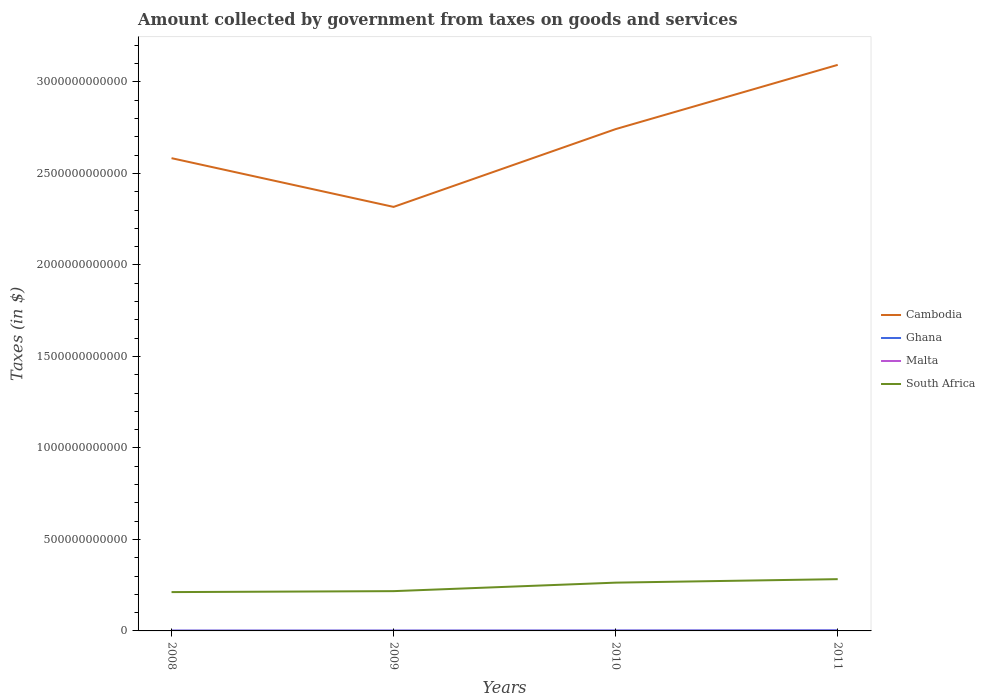Does the line corresponding to Ghana intersect with the line corresponding to Malta?
Your answer should be compact. No. Is the number of lines equal to the number of legend labels?
Offer a very short reply. Yes. Across all years, what is the maximum amount collected by government from taxes on goods and services in South Africa?
Provide a succinct answer. 2.12e+11. In which year was the amount collected by government from taxes on goods and services in South Africa maximum?
Your answer should be very brief. 2008. What is the total amount collected by government from taxes on goods and services in South Africa in the graph?
Make the answer very short. -1.90e+1. What is the difference between the highest and the second highest amount collected by government from taxes on goods and services in Cambodia?
Provide a short and direct response. 7.76e+11. How many lines are there?
Offer a terse response. 4. How many years are there in the graph?
Provide a short and direct response. 4. What is the difference between two consecutive major ticks on the Y-axis?
Provide a short and direct response. 5.00e+11. How are the legend labels stacked?
Ensure brevity in your answer.  Vertical. What is the title of the graph?
Your response must be concise. Amount collected by government from taxes on goods and services. What is the label or title of the Y-axis?
Ensure brevity in your answer.  Taxes (in $). What is the Taxes (in $) in Cambodia in 2008?
Provide a short and direct response. 2.58e+12. What is the Taxes (in $) of Ghana in 2008?
Offer a terse response. 1.86e+09. What is the Taxes (in $) of Malta in 2008?
Provide a short and direct response. 7.96e+08. What is the Taxes (in $) of South Africa in 2008?
Keep it short and to the point. 2.12e+11. What is the Taxes (in $) in Cambodia in 2009?
Provide a short and direct response. 2.32e+12. What is the Taxes (in $) in Ghana in 2009?
Give a very brief answer. 2.00e+09. What is the Taxes (in $) of Malta in 2009?
Provide a succinct answer. 8.01e+08. What is the Taxes (in $) in South Africa in 2009?
Your answer should be compact. 2.17e+11. What is the Taxes (in $) in Cambodia in 2010?
Ensure brevity in your answer.  2.74e+12. What is the Taxes (in $) of Ghana in 2010?
Make the answer very short. 2.44e+09. What is the Taxes (in $) in Malta in 2010?
Ensure brevity in your answer.  8.29e+08. What is the Taxes (in $) of South Africa in 2010?
Your answer should be very brief. 2.64e+11. What is the Taxes (in $) in Cambodia in 2011?
Your answer should be very brief. 3.09e+12. What is the Taxes (in $) of Ghana in 2011?
Your answer should be compact. 3.55e+09. What is the Taxes (in $) in Malta in 2011?
Give a very brief answer. 8.92e+08. What is the Taxes (in $) in South Africa in 2011?
Give a very brief answer. 2.83e+11. Across all years, what is the maximum Taxes (in $) in Cambodia?
Provide a short and direct response. 3.09e+12. Across all years, what is the maximum Taxes (in $) of Ghana?
Make the answer very short. 3.55e+09. Across all years, what is the maximum Taxes (in $) of Malta?
Give a very brief answer. 8.92e+08. Across all years, what is the maximum Taxes (in $) of South Africa?
Keep it short and to the point. 2.83e+11. Across all years, what is the minimum Taxes (in $) in Cambodia?
Make the answer very short. 2.32e+12. Across all years, what is the minimum Taxes (in $) of Ghana?
Your answer should be compact. 1.86e+09. Across all years, what is the minimum Taxes (in $) of Malta?
Offer a terse response. 7.96e+08. Across all years, what is the minimum Taxes (in $) in South Africa?
Provide a short and direct response. 2.12e+11. What is the total Taxes (in $) of Cambodia in the graph?
Provide a succinct answer. 1.07e+13. What is the total Taxes (in $) of Ghana in the graph?
Offer a very short reply. 9.85e+09. What is the total Taxes (in $) of Malta in the graph?
Provide a short and direct response. 3.32e+09. What is the total Taxes (in $) in South Africa in the graph?
Your answer should be very brief. 9.76e+11. What is the difference between the Taxes (in $) of Cambodia in 2008 and that in 2009?
Provide a succinct answer. 2.66e+11. What is the difference between the Taxes (in $) of Ghana in 2008 and that in 2009?
Make the answer very short. -1.33e+08. What is the difference between the Taxes (in $) of Malta in 2008 and that in 2009?
Your answer should be very brief. -4.79e+06. What is the difference between the Taxes (in $) of South Africa in 2008 and that in 2009?
Offer a very short reply. -5.19e+09. What is the difference between the Taxes (in $) of Cambodia in 2008 and that in 2010?
Provide a succinct answer. -1.59e+11. What is the difference between the Taxes (in $) in Ghana in 2008 and that in 2010?
Your answer should be very brief. -5.73e+08. What is the difference between the Taxes (in $) in Malta in 2008 and that in 2010?
Provide a succinct answer. -3.33e+07. What is the difference between the Taxes (in $) of South Africa in 2008 and that in 2010?
Ensure brevity in your answer.  -5.17e+1. What is the difference between the Taxes (in $) in Cambodia in 2008 and that in 2011?
Provide a succinct answer. -5.10e+11. What is the difference between the Taxes (in $) in Ghana in 2008 and that in 2011?
Give a very brief answer. -1.69e+09. What is the difference between the Taxes (in $) of Malta in 2008 and that in 2011?
Ensure brevity in your answer.  -9.64e+07. What is the difference between the Taxes (in $) in South Africa in 2008 and that in 2011?
Provide a succinct answer. -7.07e+1. What is the difference between the Taxes (in $) of Cambodia in 2009 and that in 2010?
Give a very brief answer. -4.25e+11. What is the difference between the Taxes (in $) in Ghana in 2009 and that in 2010?
Offer a very short reply. -4.40e+08. What is the difference between the Taxes (in $) in Malta in 2009 and that in 2010?
Keep it short and to the point. -2.85e+07. What is the difference between the Taxes (in $) of South Africa in 2009 and that in 2010?
Offer a terse response. -4.65e+1. What is the difference between the Taxes (in $) in Cambodia in 2009 and that in 2011?
Offer a terse response. -7.76e+11. What is the difference between the Taxes (in $) in Ghana in 2009 and that in 2011?
Offer a terse response. -1.55e+09. What is the difference between the Taxes (in $) of Malta in 2009 and that in 2011?
Your answer should be very brief. -9.16e+07. What is the difference between the Taxes (in $) of South Africa in 2009 and that in 2011?
Provide a succinct answer. -6.55e+1. What is the difference between the Taxes (in $) in Cambodia in 2010 and that in 2011?
Ensure brevity in your answer.  -3.51e+11. What is the difference between the Taxes (in $) of Ghana in 2010 and that in 2011?
Ensure brevity in your answer.  -1.11e+09. What is the difference between the Taxes (in $) of Malta in 2010 and that in 2011?
Make the answer very short. -6.32e+07. What is the difference between the Taxes (in $) of South Africa in 2010 and that in 2011?
Provide a succinct answer. -1.90e+1. What is the difference between the Taxes (in $) of Cambodia in 2008 and the Taxes (in $) of Ghana in 2009?
Make the answer very short. 2.58e+12. What is the difference between the Taxes (in $) in Cambodia in 2008 and the Taxes (in $) in Malta in 2009?
Your response must be concise. 2.58e+12. What is the difference between the Taxes (in $) in Cambodia in 2008 and the Taxes (in $) in South Africa in 2009?
Your answer should be very brief. 2.37e+12. What is the difference between the Taxes (in $) in Ghana in 2008 and the Taxes (in $) in Malta in 2009?
Offer a very short reply. 1.06e+09. What is the difference between the Taxes (in $) in Ghana in 2008 and the Taxes (in $) in South Africa in 2009?
Ensure brevity in your answer.  -2.16e+11. What is the difference between the Taxes (in $) of Malta in 2008 and the Taxes (in $) of South Africa in 2009?
Ensure brevity in your answer.  -2.17e+11. What is the difference between the Taxes (in $) in Cambodia in 2008 and the Taxes (in $) in Ghana in 2010?
Offer a terse response. 2.58e+12. What is the difference between the Taxes (in $) in Cambodia in 2008 and the Taxes (in $) in Malta in 2010?
Ensure brevity in your answer.  2.58e+12. What is the difference between the Taxes (in $) of Cambodia in 2008 and the Taxes (in $) of South Africa in 2010?
Provide a succinct answer. 2.32e+12. What is the difference between the Taxes (in $) of Ghana in 2008 and the Taxes (in $) of Malta in 2010?
Your response must be concise. 1.03e+09. What is the difference between the Taxes (in $) of Ghana in 2008 and the Taxes (in $) of South Africa in 2010?
Keep it short and to the point. -2.62e+11. What is the difference between the Taxes (in $) in Malta in 2008 and the Taxes (in $) in South Africa in 2010?
Offer a very short reply. -2.63e+11. What is the difference between the Taxes (in $) in Cambodia in 2008 and the Taxes (in $) in Ghana in 2011?
Provide a succinct answer. 2.58e+12. What is the difference between the Taxes (in $) in Cambodia in 2008 and the Taxes (in $) in Malta in 2011?
Ensure brevity in your answer.  2.58e+12. What is the difference between the Taxes (in $) of Cambodia in 2008 and the Taxes (in $) of South Africa in 2011?
Your answer should be very brief. 2.30e+12. What is the difference between the Taxes (in $) of Ghana in 2008 and the Taxes (in $) of Malta in 2011?
Ensure brevity in your answer.  9.71e+08. What is the difference between the Taxes (in $) in Ghana in 2008 and the Taxes (in $) in South Africa in 2011?
Your answer should be compact. -2.81e+11. What is the difference between the Taxes (in $) of Malta in 2008 and the Taxes (in $) of South Africa in 2011?
Your answer should be compact. -2.82e+11. What is the difference between the Taxes (in $) in Cambodia in 2009 and the Taxes (in $) in Ghana in 2010?
Keep it short and to the point. 2.31e+12. What is the difference between the Taxes (in $) of Cambodia in 2009 and the Taxes (in $) of Malta in 2010?
Provide a short and direct response. 2.32e+12. What is the difference between the Taxes (in $) of Cambodia in 2009 and the Taxes (in $) of South Africa in 2010?
Your answer should be very brief. 2.05e+12. What is the difference between the Taxes (in $) of Ghana in 2009 and the Taxes (in $) of Malta in 2010?
Provide a short and direct response. 1.17e+09. What is the difference between the Taxes (in $) in Ghana in 2009 and the Taxes (in $) in South Africa in 2010?
Give a very brief answer. -2.62e+11. What is the difference between the Taxes (in $) of Malta in 2009 and the Taxes (in $) of South Africa in 2010?
Offer a very short reply. -2.63e+11. What is the difference between the Taxes (in $) of Cambodia in 2009 and the Taxes (in $) of Ghana in 2011?
Your response must be concise. 2.31e+12. What is the difference between the Taxes (in $) of Cambodia in 2009 and the Taxes (in $) of Malta in 2011?
Keep it short and to the point. 2.32e+12. What is the difference between the Taxes (in $) in Cambodia in 2009 and the Taxes (in $) in South Africa in 2011?
Your answer should be very brief. 2.03e+12. What is the difference between the Taxes (in $) of Ghana in 2009 and the Taxes (in $) of Malta in 2011?
Offer a very short reply. 1.10e+09. What is the difference between the Taxes (in $) of Ghana in 2009 and the Taxes (in $) of South Africa in 2011?
Provide a succinct answer. -2.81e+11. What is the difference between the Taxes (in $) of Malta in 2009 and the Taxes (in $) of South Africa in 2011?
Ensure brevity in your answer.  -2.82e+11. What is the difference between the Taxes (in $) in Cambodia in 2010 and the Taxes (in $) in Ghana in 2011?
Your response must be concise. 2.74e+12. What is the difference between the Taxes (in $) of Cambodia in 2010 and the Taxes (in $) of Malta in 2011?
Offer a terse response. 2.74e+12. What is the difference between the Taxes (in $) in Cambodia in 2010 and the Taxes (in $) in South Africa in 2011?
Your answer should be very brief. 2.46e+12. What is the difference between the Taxes (in $) in Ghana in 2010 and the Taxes (in $) in Malta in 2011?
Offer a terse response. 1.54e+09. What is the difference between the Taxes (in $) in Ghana in 2010 and the Taxes (in $) in South Africa in 2011?
Your answer should be compact. -2.80e+11. What is the difference between the Taxes (in $) of Malta in 2010 and the Taxes (in $) of South Africa in 2011?
Ensure brevity in your answer.  -2.82e+11. What is the average Taxes (in $) of Cambodia per year?
Provide a short and direct response. 2.68e+12. What is the average Taxes (in $) of Ghana per year?
Offer a very short reply. 2.46e+09. What is the average Taxes (in $) of Malta per year?
Provide a succinct answer. 8.30e+08. What is the average Taxes (in $) in South Africa per year?
Provide a short and direct response. 2.44e+11. In the year 2008, what is the difference between the Taxes (in $) of Cambodia and Taxes (in $) of Ghana?
Provide a succinct answer. 2.58e+12. In the year 2008, what is the difference between the Taxes (in $) in Cambodia and Taxes (in $) in Malta?
Provide a succinct answer. 2.58e+12. In the year 2008, what is the difference between the Taxes (in $) of Cambodia and Taxes (in $) of South Africa?
Ensure brevity in your answer.  2.37e+12. In the year 2008, what is the difference between the Taxes (in $) in Ghana and Taxes (in $) in Malta?
Your answer should be very brief. 1.07e+09. In the year 2008, what is the difference between the Taxes (in $) in Ghana and Taxes (in $) in South Africa?
Provide a short and direct response. -2.10e+11. In the year 2008, what is the difference between the Taxes (in $) in Malta and Taxes (in $) in South Africa?
Provide a short and direct response. -2.11e+11. In the year 2009, what is the difference between the Taxes (in $) of Cambodia and Taxes (in $) of Ghana?
Offer a terse response. 2.32e+12. In the year 2009, what is the difference between the Taxes (in $) of Cambodia and Taxes (in $) of Malta?
Make the answer very short. 2.32e+12. In the year 2009, what is the difference between the Taxes (in $) of Cambodia and Taxes (in $) of South Africa?
Offer a terse response. 2.10e+12. In the year 2009, what is the difference between the Taxes (in $) in Ghana and Taxes (in $) in Malta?
Offer a terse response. 1.20e+09. In the year 2009, what is the difference between the Taxes (in $) in Ghana and Taxes (in $) in South Africa?
Ensure brevity in your answer.  -2.15e+11. In the year 2009, what is the difference between the Taxes (in $) of Malta and Taxes (in $) of South Africa?
Provide a succinct answer. -2.17e+11. In the year 2010, what is the difference between the Taxes (in $) of Cambodia and Taxes (in $) of Ghana?
Make the answer very short. 2.74e+12. In the year 2010, what is the difference between the Taxes (in $) in Cambodia and Taxes (in $) in Malta?
Your answer should be very brief. 2.74e+12. In the year 2010, what is the difference between the Taxes (in $) in Cambodia and Taxes (in $) in South Africa?
Your answer should be compact. 2.48e+12. In the year 2010, what is the difference between the Taxes (in $) of Ghana and Taxes (in $) of Malta?
Your answer should be compact. 1.61e+09. In the year 2010, what is the difference between the Taxes (in $) of Ghana and Taxes (in $) of South Africa?
Offer a very short reply. -2.61e+11. In the year 2010, what is the difference between the Taxes (in $) in Malta and Taxes (in $) in South Africa?
Offer a terse response. -2.63e+11. In the year 2011, what is the difference between the Taxes (in $) of Cambodia and Taxes (in $) of Ghana?
Ensure brevity in your answer.  3.09e+12. In the year 2011, what is the difference between the Taxes (in $) of Cambodia and Taxes (in $) of Malta?
Your answer should be very brief. 3.09e+12. In the year 2011, what is the difference between the Taxes (in $) of Cambodia and Taxes (in $) of South Africa?
Offer a very short reply. 2.81e+12. In the year 2011, what is the difference between the Taxes (in $) of Ghana and Taxes (in $) of Malta?
Your response must be concise. 2.66e+09. In the year 2011, what is the difference between the Taxes (in $) in Ghana and Taxes (in $) in South Africa?
Offer a terse response. -2.79e+11. In the year 2011, what is the difference between the Taxes (in $) of Malta and Taxes (in $) of South Africa?
Keep it short and to the point. -2.82e+11. What is the ratio of the Taxes (in $) of Cambodia in 2008 to that in 2009?
Keep it short and to the point. 1.11. What is the ratio of the Taxes (in $) in Ghana in 2008 to that in 2009?
Keep it short and to the point. 0.93. What is the ratio of the Taxes (in $) in South Africa in 2008 to that in 2009?
Provide a succinct answer. 0.98. What is the ratio of the Taxes (in $) in Cambodia in 2008 to that in 2010?
Your answer should be very brief. 0.94. What is the ratio of the Taxes (in $) in Ghana in 2008 to that in 2010?
Offer a very short reply. 0.76. What is the ratio of the Taxes (in $) in Malta in 2008 to that in 2010?
Make the answer very short. 0.96. What is the ratio of the Taxes (in $) of South Africa in 2008 to that in 2010?
Your response must be concise. 0.8. What is the ratio of the Taxes (in $) of Cambodia in 2008 to that in 2011?
Ensure brevity in your answer.  0.84. What is the ratio of the Taxes (in $) of Ghana in 2008 to that in 2011?
Your response must be concise. 0.53. What is the ratio of the Taxes (in $) in Malta in 2008 to that in 2011?
Give a very brief answer. 0.89. What is the ratio of the Taxes (in $) of South Africa in 2008 to that in 2011?
Provide a short and direct response. 0.75. What is the ratio of the Taxes (in $) in Cambodia in 2009 to that in 2010?
Your answer should be very brief. 0.84. What is the ratio of the Taxes (in $) in Ghana in 2009 to that in 2010?
Offer a terse response. 0.82. What is the ratio of the Taxes (in $) of Malta in 2009 to that in 2010?
Make the answer very short. 0.97. What is the ratio of the Taxes (in $) of South Africa in 2009 to that in 2010?
Ensure brevity in your answer.  0.82. What is the ratio of the Taxes (in $) in Cambodia in 2009 to that in 2011?
Your response must be concise. 0.75. What is the ratio of the Taxes (in $) in Ghana in 2009 to that in 2011?
Make the answer very short. 0.56. What is the ratio of the Taxes (in $) in Malta in 2009 to that in 2011?
Your response must be concise. 0.9. What is the ratio of the Taxes (in $) in South Africa in 2009 to that in 2011?
Keep it short and to the point. 0.77. What is the ratio of the Taxes (in $) in Cambodia in 2010 to that in 2011?
Your answer should be compact. 0.89. What is the ratio of the Taxes (in $) of Ghana in 2010 to that in 2011?
Provide a short and direct response. 0.69. What is the ratio of the Taxes (in $) in Malta in 2010 to that in 2011?
Keep it short and to the point. 0.93. What is the ratio of the Taxes (in $) in South Africa in 2010 to that in 2011?
Your answer should be compact. 0.93. What is the difference between the highest and the second highest Taxes (in $) in Cambodia?
Provide a short and direct response. 3.51e+11. What is the difference between the highest and the second highest Taxes (in $) of Ghana?
Make the answer very short. 1.11e+09. What is the difference between the highest and the second highest Taxes (in $) of Malta?
Provide a succinct answer. 6.32e+07. What is the difference between the highest and the second highest Taxes (in $) of South Africa?
Keep it short and to the point. 1.90e+1. What is the difference between the highest and the lowest Taxes (in $) of Cambodia?
Your answer should be very brief. 7.76e+11. What is the difference between the highest and the lowest Taxes (in $) in Ghana?
Keep it short and to the point. 1.69e+09. What is the difference between the highest and the lowest Taxes (in $) of Malta?
Your response must be concise. 9.64e+07. What is the difference between the highest and the lowest Taxes (in $) of South Africa?
Your answer should be very brief. 7.07e+1. 